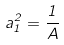<formula> <loc_0><loc_0><loc_500><loc_500>a _ { 1 } ^ { 2 } = \frac { 1 } { A }</formula> 